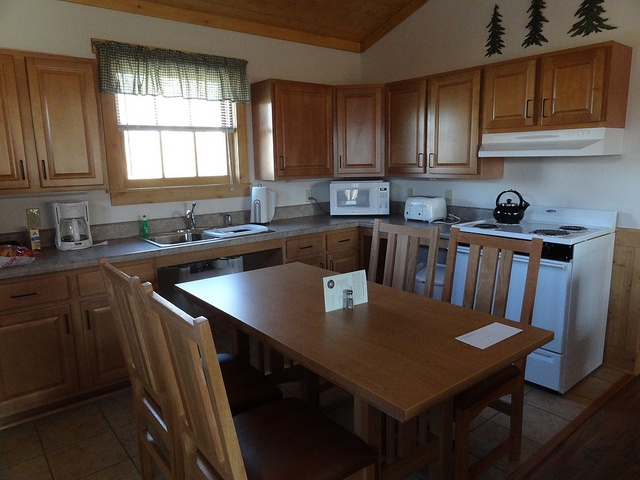Describe the objects in this image and their specific colors. I can see dining table in gray, maroon, and black tones, chair in gray, black, and maroon tones, oven in gray and black tones, chair in gray, maroon, and black tones, and chair in gray, black, and olive tones in this image. 